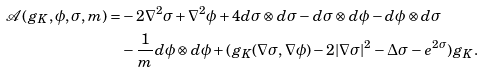<formula> <loc_0><loc_0><loc_500><loc_500>\mathcal { A } ( g _ { K } , \phi , \sigma , m ) = & - 2 \nabla ^ { 2 } \sigma + \nabla ^ { 2 } \phi + 4 d \sigma \otimes d \sigma - d \sigma \otimes d \phi - d \phi \otimes d \sigma \\ & - \frac { 1 } { m } d \phi \otimes d \phi + ( g _ { K } ( \nabla \sigma , \nabla \phi ) - 2 | \nabla \sigma | ^ { 2 } - \Delta \sigma - e ^ { 2 \sigma } ) g _ { K } .</formula> 